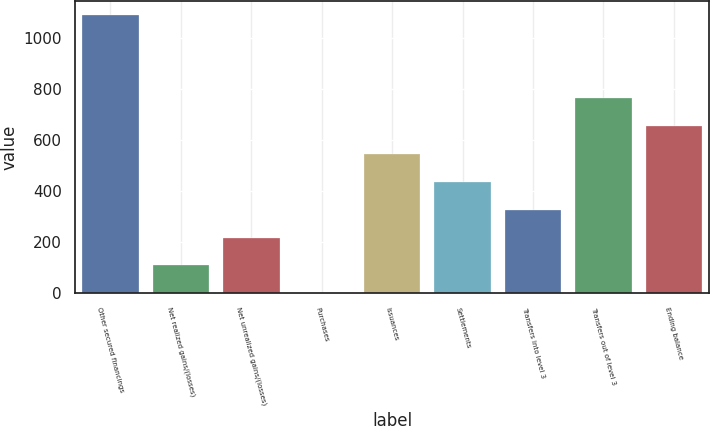Convert chart to OTSL. <chart><loc_0><loc_0><loc_500><loc_500><bar_chart><fcel>Other secured financings<fcel>Net realized gains/(losses)<fcel>Net unrealized gains/(losses)<fcel>Purchases<fcel>Issuances<fcel>Settlements<fcel>Transfers into level 3<fcel>Transfers out of level 3<fcel>Ending balance<nl><fcel>1091<fcel>110<fcel>219<fcel>1<fcel>546<fcel>437<fcel>328<fcel>764<fcel>655<nl></chart> 